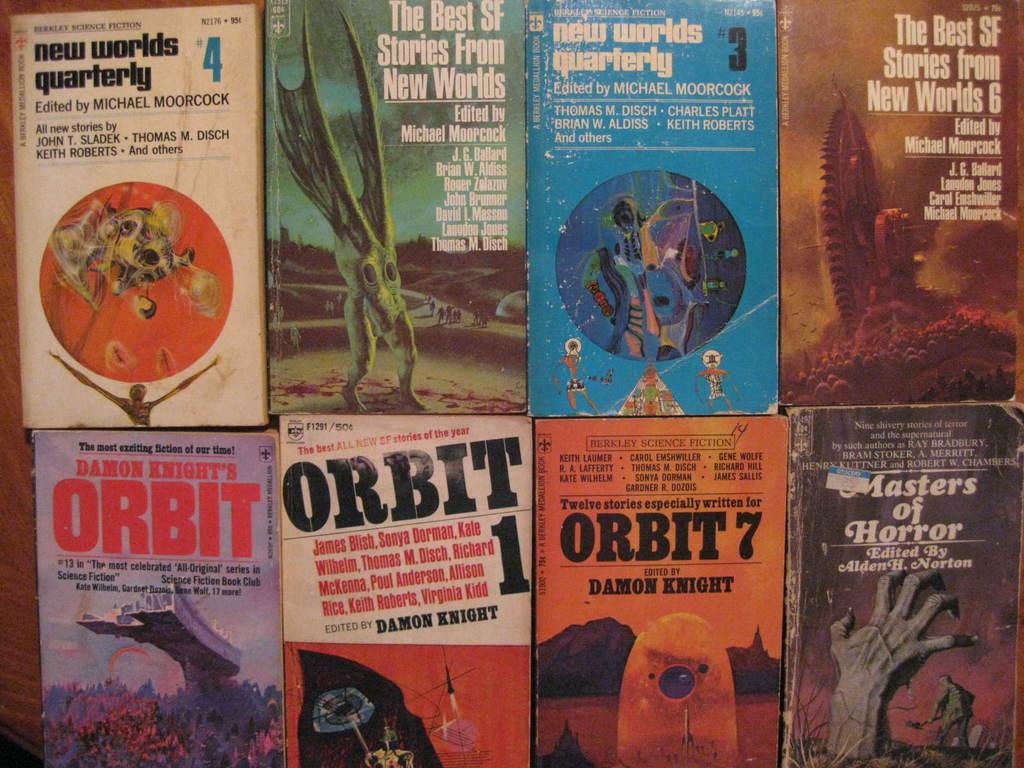<image>
Relay a brief, clear account of the picture shown. Book covers, with several titled Orbit are shown with other books. 